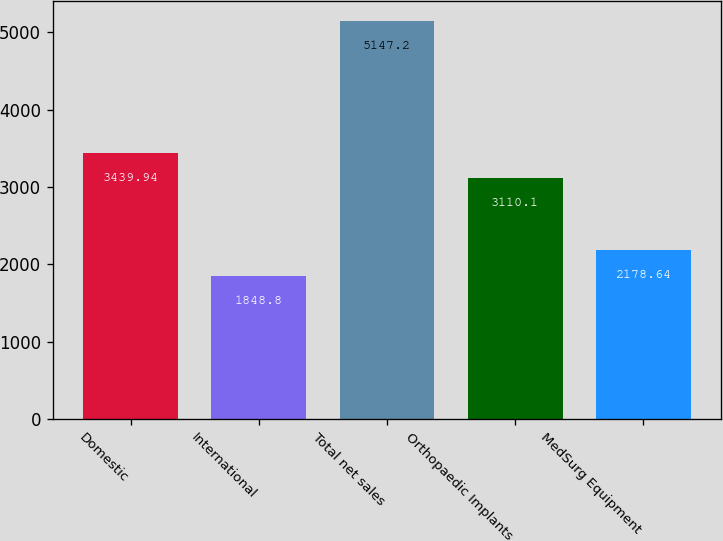Convert chart. <chart><loc_0><loc_0><loc_500><loc_500><bar_chart><fcel>Domestic<fcel>International<fcel>Total net sales<fcel>Orthopaedic Implants<fcel>MedSurg Equipment<nl><fcel>3439.94<fcel>1848.8<fcel>5147.2<fcel>3110.1<fcel>2178.64<nl></chart> 